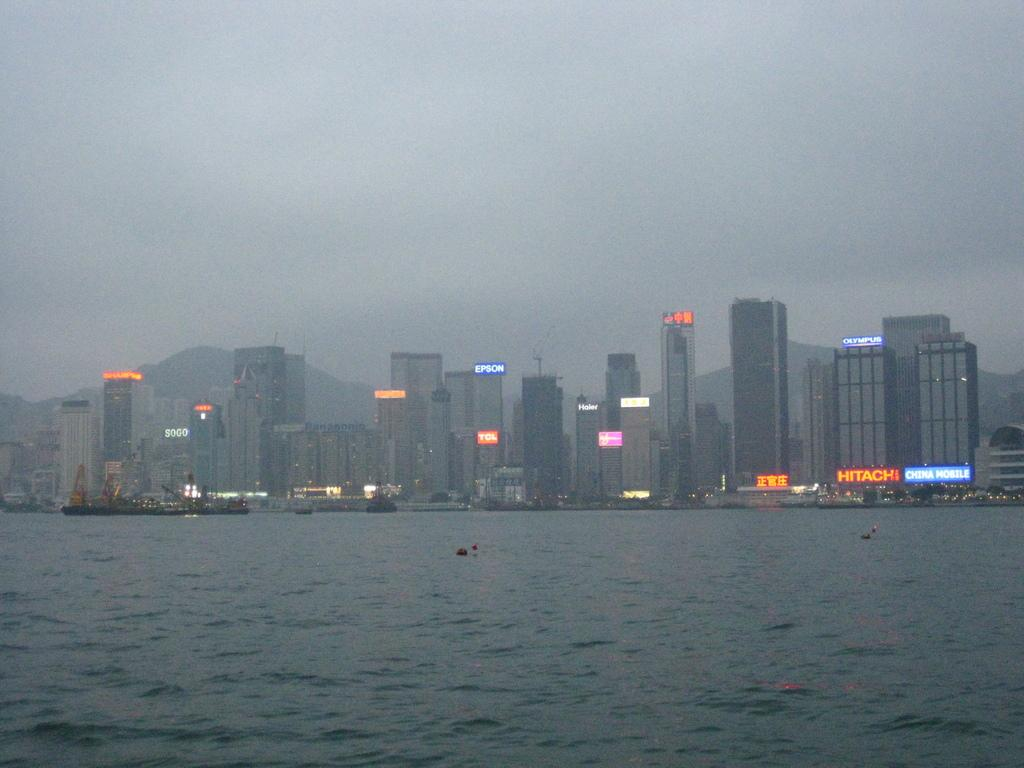What type of structures can be seen in the image? There are buildings in the image. What objects are present near the water? Boards are visible in the image. What is at the bottom of the image? There is water at the bottom of the image. What is floating on the water? Boats are visible on the water. What can be seen in the background of the image? There is sky and hills visible in the background of the image. What type of loss is being experienced by the nation in the image? There is no indication of any loss or nation in the image; it features buildings, boards, water, boats, sky, and hills. Is there a bridge connecting the hills in the image? No, there is no bridge visible in the image. 